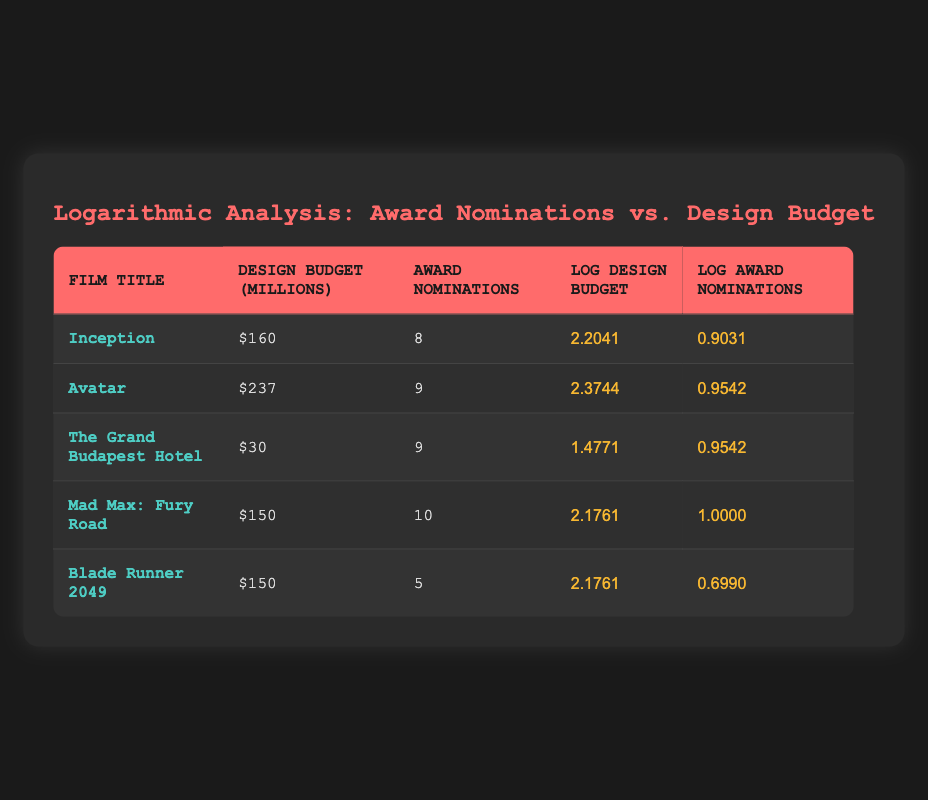What is the design budget for "Avatar"? From the table, look for the row corresponding to "Avatar," which shows a design budget of $237 million.
Answer: 237 million Which film received the highest number of award nominations? To find the film with the most nominations, compare the "Award Nominations" column. "Mad Max: Fury Road" has the highest with 10 nominations.
Answer: Mad Max: Fury Road Is the design budget for "Inception" greater than that of "Blade Runner 2049"? Check the design budgets for both films. "Inception" has a budget of $160 million, while "Blade Runner 2049" also has $150 million. Since $160 million is greater than $150 million, the statement is true.
Answer: Yes What are the total award nominations for films with a design budget above $150 million? Filter the table for films with a budget greater than $150 million: "Avatar" (9 nominations) and "Inception" (8 nominations) make a total of 9 + 8 = 17 nominations.
Answer: 17 What is the log difference in award nominations between "Mad Max: Fury Road" and "Blade Runner 2049"? Find the log values of award nominations: "Mad Max: Fury Road" is 1.0000 and "Blade Runner 2049" is 0.6990. The difference is 1.0000 - 0.6990 = 0.3010.
Answer: 0.3010 